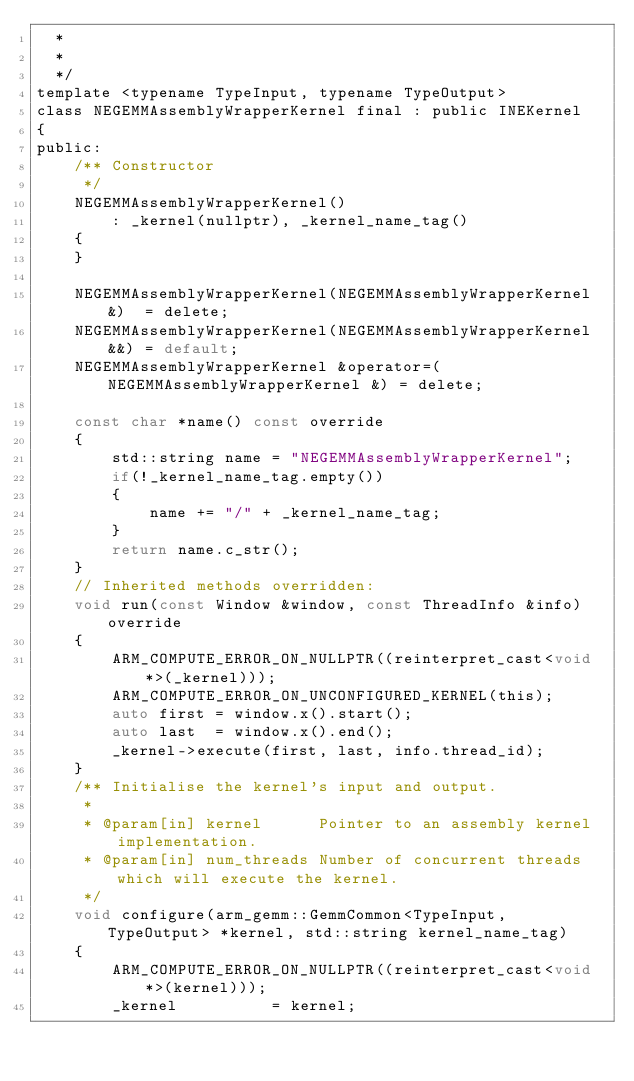<code> <loc_0><loc_0><loc_500><loc_500><_C_>  *
  *
  */
template <typename TypeInput, typename TypeOutput>
class NEGEMMAssemblyWrapperKernel final : public INEKernel
{
public:
    /** Constructor
     */
    NEGEMMAssemblyWrapperKernel()
        : _kernel(nullptr), _kernel_name_tag()
    {
    }

    NEGEMMAssemblyWrapperKernel(NEGEMMAssemblyWrapperKernel &)  = delete;
    NEGEMMAssemblyWrapperKernel(NEGEMMAssemblyWrapperKernel &&) = default;
    NEGEMMAssemblyWrapperKernel &operator=(NEGEMMAssemblyWrapperKernel &) = delete;

    const char *name() const override
    {
        std::string name = "NEGEMMAssemblyWrapperKernel";
        if(!_kernel_name_tag.empty())
        {
            name += "/" + _kernel_name_tag;
        }
        return name.c_str();
    }
    // Inherited methods overridden:
    void run(const Window &window, const ThreadInfo &info) override
    {
        ARM_COMPUTE_ERROR_ON_NULLPTR((reinterpret_cast<void *>(_kernel)));
        ARM_COMPUTE_ERROR_ON_UNCONFIGURED_KERNEL(this);
        auto first = window.x().start();
        auto last  = window.x().end();
        _kernel->execute(first, last, info.thread_id);
    }
    /** Initialise the kernel's input and output.
     *
     * @param[in] kernel      Pointer to an assembly kernel implementation.
     * @param[in] num_threads Number of concurrent threads which will execute the kernel.
     */
    void configure(arm_gemm::GemmCommon<TypeInput, TypeOutput> *kernel, std::string kernel_name_tag)
    {
        ARM_COMPUTE_ERROR_ON_NULLPTR((reinterpret_cast<void *>(kernel)));
        _kernel          = kernel;</code> 